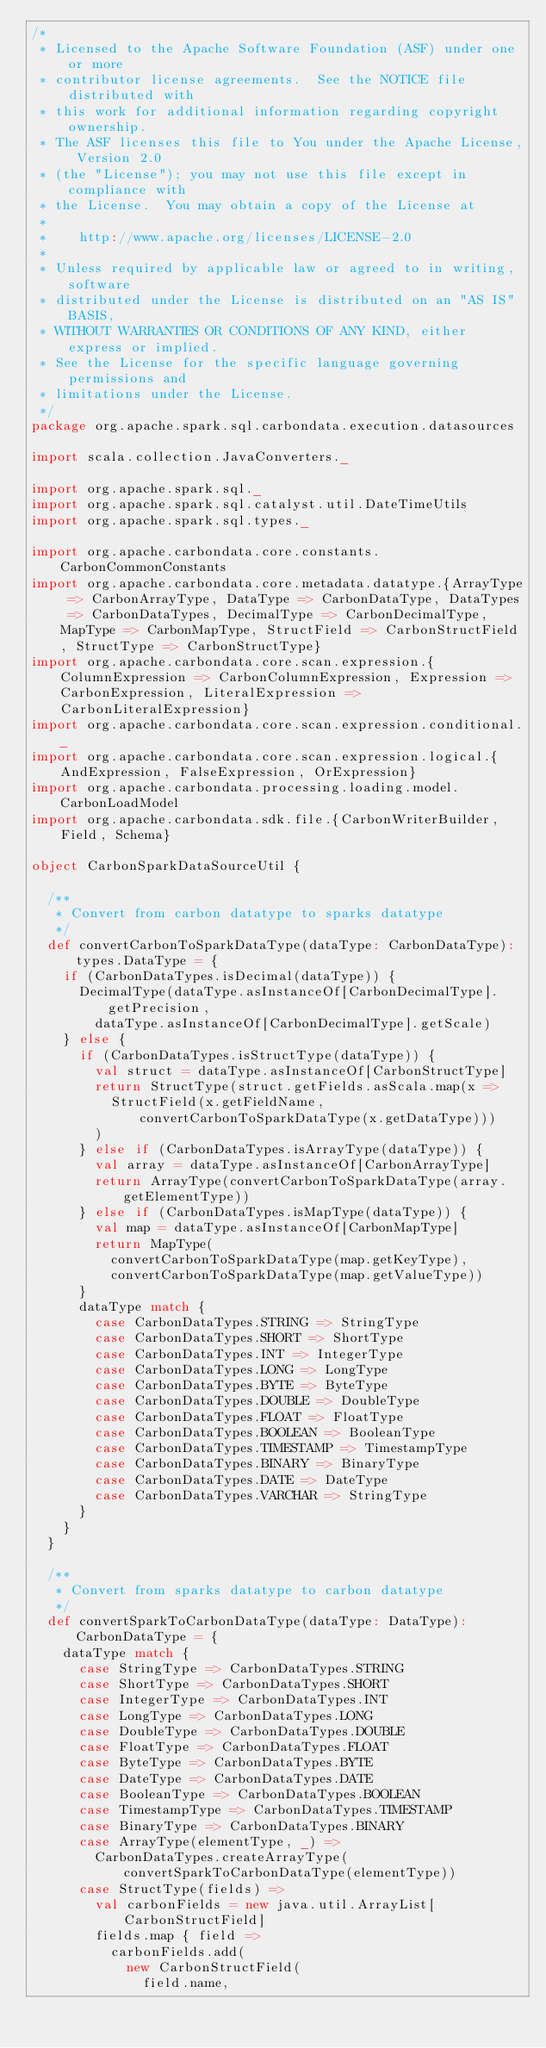<code> <loc_0><loc_0><loc_500><loc_500><_Scala_>/*
 * Licensed to the Apache Software Foundation (ASF) under one or more
 * contributor license agreements.  See the NOTICE file distributed with
 * this work for additional information regarding copyright ownership.
 * The ASF licenses this file to You under the Apache License, Version 2.0
 * (the "License"); you may not use this file except in compliance with
 * the License.  You may obtain a copy of the License at
 *
 *    http://www.apache.org/licenses/LICENSE-2.0
 *
 * Unless required by applicable law or agreed to in writing, software
 * distributed under the License is distributed on an "AS IS" BASIS,
 * WITHOUT WARRANTIES OR CONDITIONS OF ANY KIND, either express or implied.
 * See the License for the specific language governing permissions and
 * limitations under the License.
 */
package org.apache.spark.sql.carbondata.execution.datasources

import scala.collection.JavaConverters._

import org.apache.spark.sql._
import org.apache.spark.sql.catalyst.util.DateTimeUtils
import org.apache.spark.sql.types._

import org.apache.carbondata.core.constants.CarbonCommonConstants
import org.apache.carbondata.core.metadata.datatype.{ArrayType => CarbonArrayType, DataType => CarbonDataType, DataTypes => CarbonDataTypes, DecimalType => CarbonDecimalType, MapType => CarbonMapType, StructField => CarbonStructField, StructType => CarbonStructType}
import org.apache.carbondata.core.scan.expression.{ColumnExpression => CarbonColumnExpression, Expression => CarbonExpression, LiteralExpression => CarbonLiteralExpression}
import org.apache.carbondata.core.scan.expression.conditional._
import org.apache.carbondata.core.scan.expression.logical.{AndExpression, FalseExpression, OrExpression}
import org.apache.carbondata.processing.loading.model.CarbonLoadModel
import org.apache.carbondata.sdk.file.{CarbonWriterBuilder, Field, Schema}

object CarbonSparkDataSourceUtil {

  /**
   * Convert from carbon datatype to sparks datatype
   */
  def convertCarbonToSparkDataType(dataType: CarbonDataType): types.DataType = {
    if (CarbonDataTypes.isDecimal(dataType)) {
      DecimalType(dataType.asInstanceOf[CarbonDecimalType].getPrecision,
        dataType.asInstanceOf[CarbonDecimalType].getScale)
    } else {
      if (CarbonDataTypes.isStructType(dataType)) {
        val struct = dataType.asInstanceOf[CarbonStructType]
        return StructType(struct.getFields.asScala.map(x =>
          StructField(x.getFieldName, convertCarbonToSparkDataType(x.getDataType)))
        )
      } else if (CarbonDataTypes.isArrayType(dataType)) {
        val array = dataType.asInstanceOf[CarbonArrayType]
        return ArrayType(convertCarbonToSparkDataType(array.getElementType))
      } else if (CarbonDataTypes.isMapType(dataType)) {
        val map = dataType.asInstanceOf[CarbonMapType]
        return MapType(
          convertCarbonToSparkDataType(map.getKeyType),
          convertCarbonToSparkDataType(map.getValueType))
      }
      dataType match {
        case CarbonDataTypes.STRING => StringType
        case CarbonDataTypes.SHORT => ShortType
        case CarbonDataTypes.INT => IntegerType
        case CarbonDataTypes.LONG => LongType
        case CarbonDataTypes.BYTE => ByteType
        case CarbonDataTypes.DOUBLE => DoubleType
        case CarbonDataTypes.FLOAT => FloatType
        case CarbonDataTypes.BOOLEAN => BooleanType
        case CarbonDataTypes.TIMESTAMP => TimestampType
        case CarbonDataTypes.BINARY => BinaryType
        case CarbonDataTypes.DATE => DateType
        case CarbonDataTypes.VARCHAR => StringType
      }
    }
  }

  /**
   * Convert from sparks datatype to carbon datatype
   */
  def convertSparkToCarbonDataType(dataType: DataType): CarbonDataType = {
    dataType match {
      case StringType => CarbonDataTypes.STRING
      case ShortType => CarbonDataTypes.SHORT
      case IntegerType => CarbonDataTypes.INT
      case LongType => CarbonDataTypes.LONG
      case DoubleType => CarbonDataTypes.DOUBLE
      case FloatType => CarbonDataTypes.FLOAT
      case ByteType => CarbonDataTypes.BYTE
      case DateType => CarbonDataTypes.DATE
      case BooleanType => CarbonDataTypes.BOOLEAN
      case TimestampType => CarbonDataTypes.TIMESTAMP
      case BinaryType => CarbonDataTypes.BINARY
      case ArrayType(elementType, _) =>
        CarbonDataTypes.createArrayType(convertSparkToCarbonDataType(elementType))
      case StructType(fields) =>
        val carbonFields = new java.util.ArrayList[CarbonStructField]
        fields.map { field =>
          carbonFields.add(
            new CarbonStructField(
              field.name,</code> 